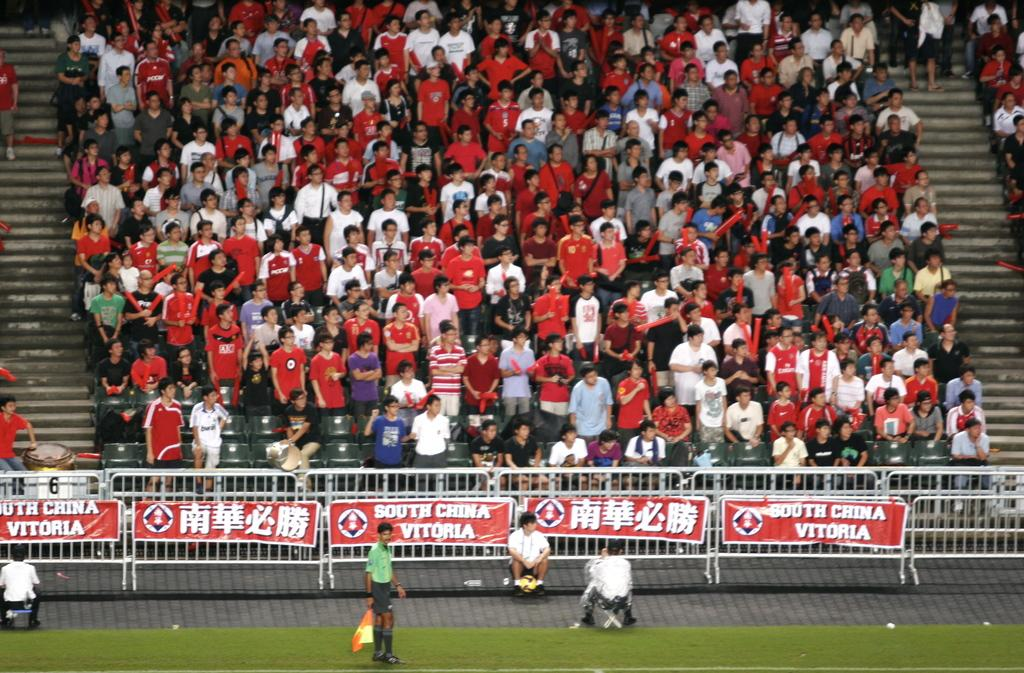<image>
Create a compact narrative representing the image presented. The crowd is watching a game sponsored by South China Vitoria. 